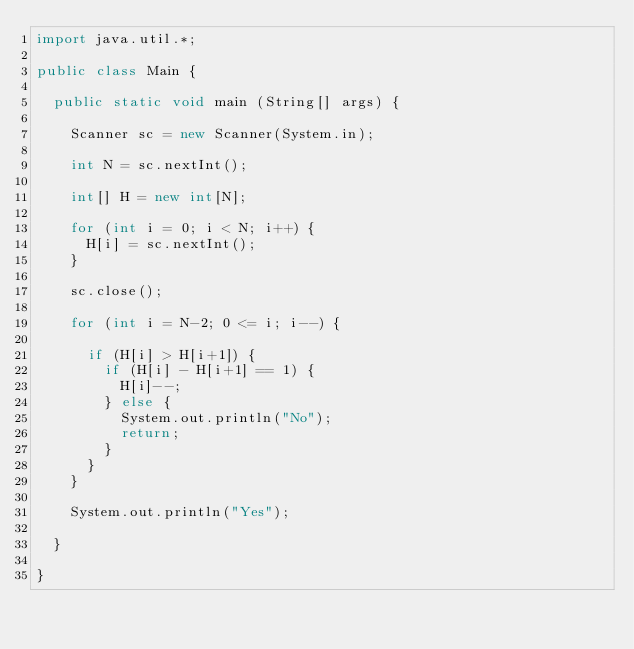Convert code to text. <code><loc_0><loc_0><loc_500><loc_500><_Java_>import java.util.*;

public class Main {

  public static void main (String[] args) {

    Scanner sc = new Scanner(System.in);
    
    int N = sc.nextInt();
    
    int[] H = new int[N];

    for (int i = 0; i < N; i++) {
      H[i] = sc.nextInt();
    }

    sc.close();

    for (int i = N-2; 0 <= i; i--) {

      if (H[i] > H[i+1]) {
        if (H[i] - H[i+1] == 1) {
          H[i]--;
        } else {
          System.out.println("No");
          return;
        }
      }
    }

    System.out.println("Yes");
    
  }

}</code> 